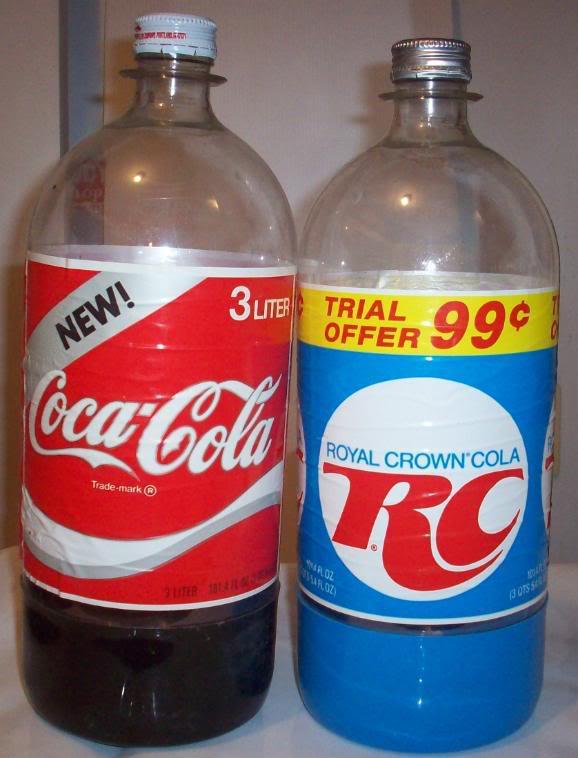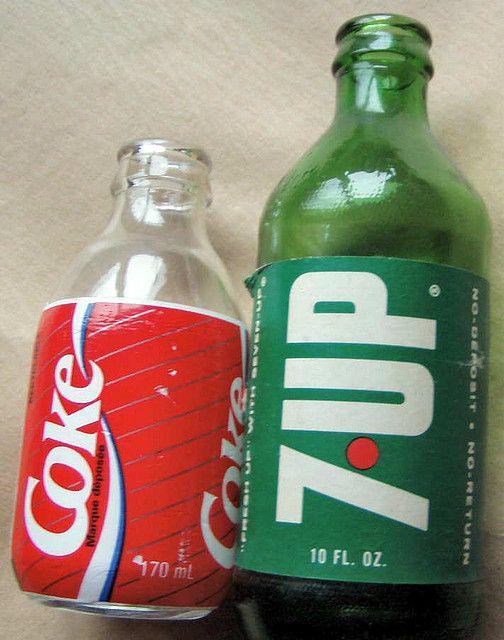The first image is the image on the left, the second image is the image on the right. Considering the images on both sides, is "There is one bottle in each image." valid? Answer yes or no. No. The first image is the image on the left, the second image is the image on the right. Assess this claim about the two images: "The bottle in one of the images could be called a jug.". Correct or not? Answer yes or no. No. 